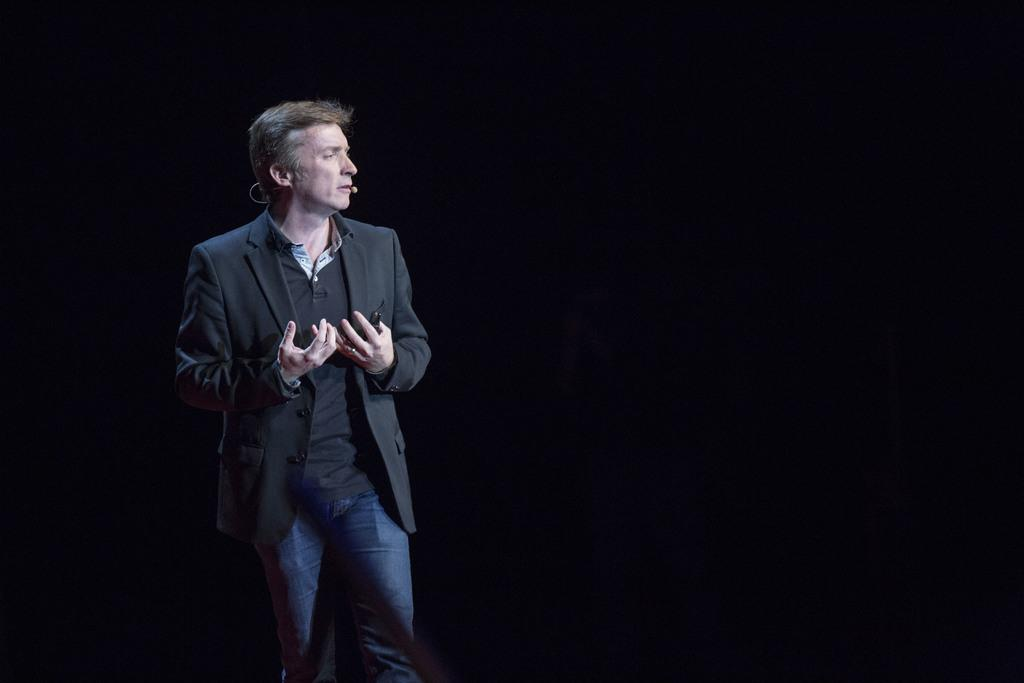What is present in the image? There is a man in the image. What is the man holding in the image? The man is holding something. Can you describe the man's appearance in the image? The man has a mic attached to his head. What is the color of the background in the image? The background of the image is dark. What type of cart can be seen in the image? There is no cart present in the image. What sense does the man appear to be using in the image? The image does not provide information about which sense the man is using. 